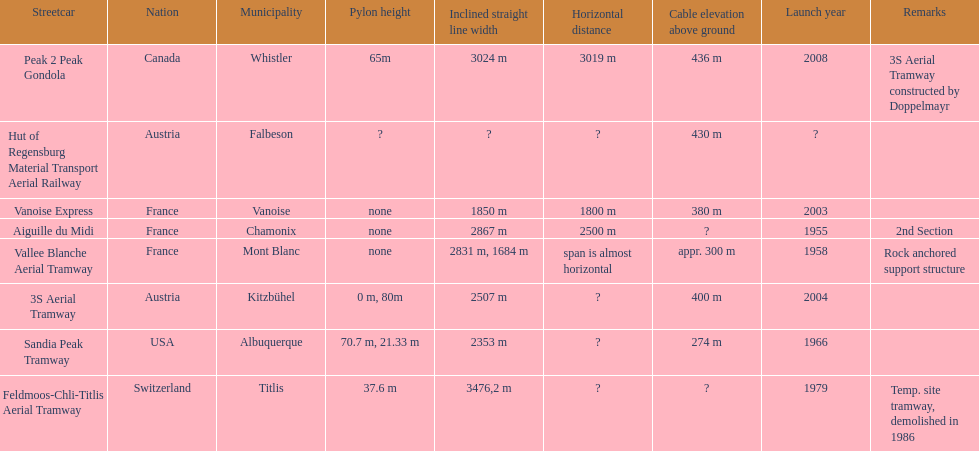Was the peak 2 peak gondola inaugurated before the vanoise express? No. 